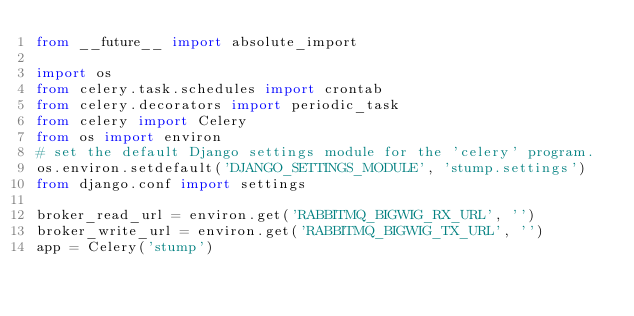<code> <loc_0><loc_0><loc_500><loc_500><_Python_>from __future__ import absolute_import

import os
from celery.task.schedules import crontab
from celery.decorators import periodic_task
from celery import Celery
from os import environ
# set the default Django settings module for the 'celery' program.
os.environ.setdefault('DJANGO_SETTINGS_MODULE', 'stump.settings')
from django.conf import settings 

broker_read_url = environ.get('RABBITMQ_BIGWIG_RX_URL', '')
broker_write_url = environ.get('RABBITMQ_BIGWIG_TX_URL', '')
app = Celery('stump')
</code> 